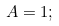Convert formula to latex. <formula><loc_0><loc_0><loc_500><loc_500>\, A = 1 ; \,</formula> 